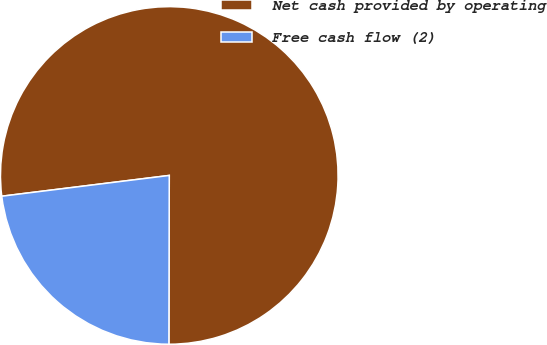Convert chart. <chart><loc_0><loc_0><loc_500><loc_500><pie_chart><fcel>Net cash provided by operating<fcel>Free cash flow (2)<nl><fcel>77.0%<fcel>23.0%<nl></chart> 